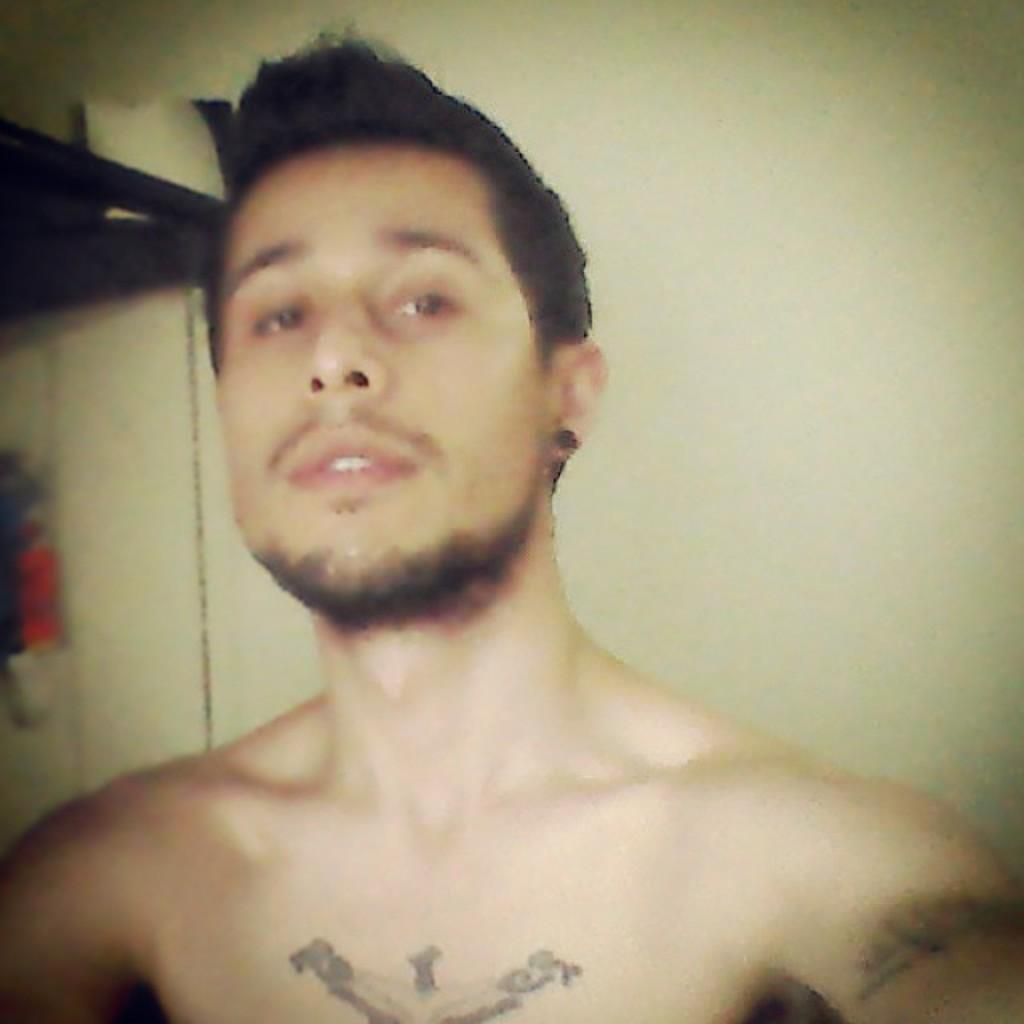What is present in the image? There is a person in the image. Can you describe any distinguishing features of the person? The person has a tattoo on their body. What else can be seen in the image besides the person? There is an unspecified object to the side of the person. What type of prose is being recited by the person in the image? There is no indication in the image that the person is reciting any prose, so it cannot be determined from the picture. 